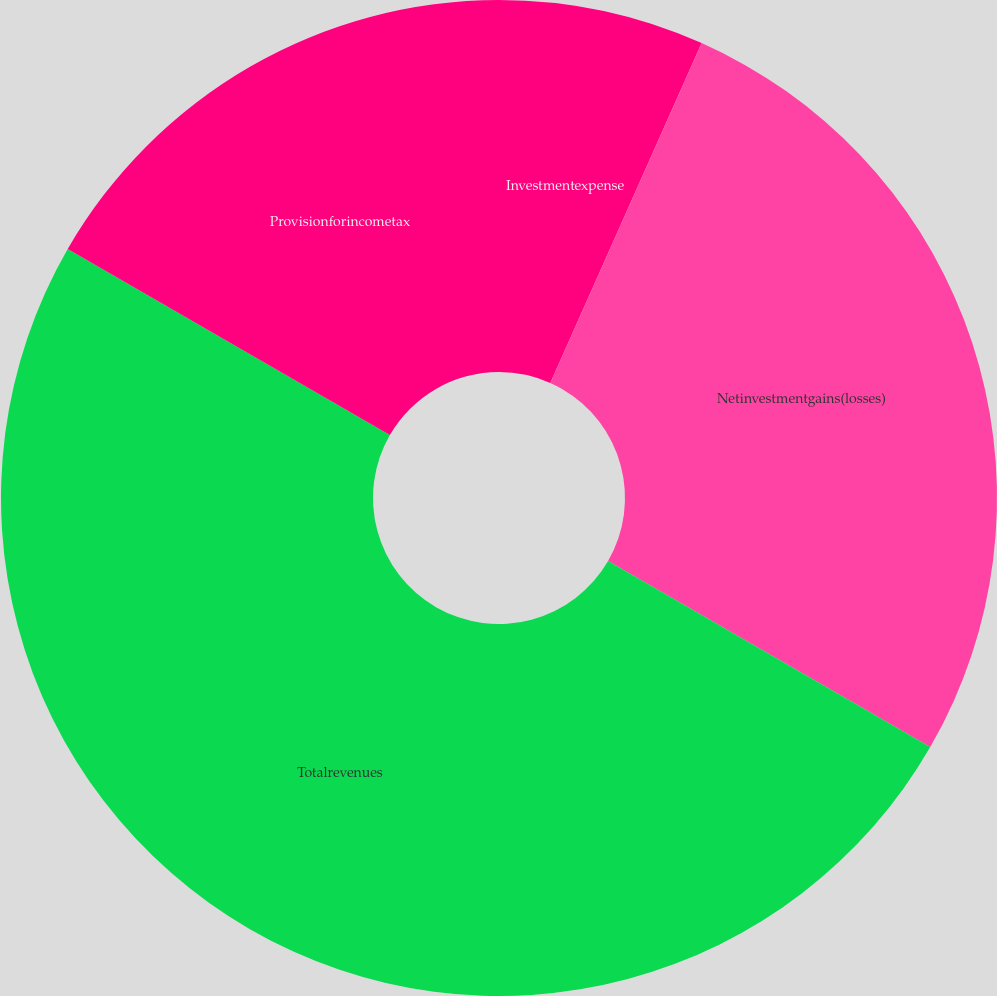<chart> <loc_0><loc_0><loc_500><loc_500><pie_chart><fcel>Investmentexpense<fcel>Netinvestmentgains(losses)<fcel>Totalrevenues<fcel>Provisionforincometax<nl><fcel>6.67%<fcel>26.67%<fcel>50.0%<fcel>16.67%<nl></chart> 